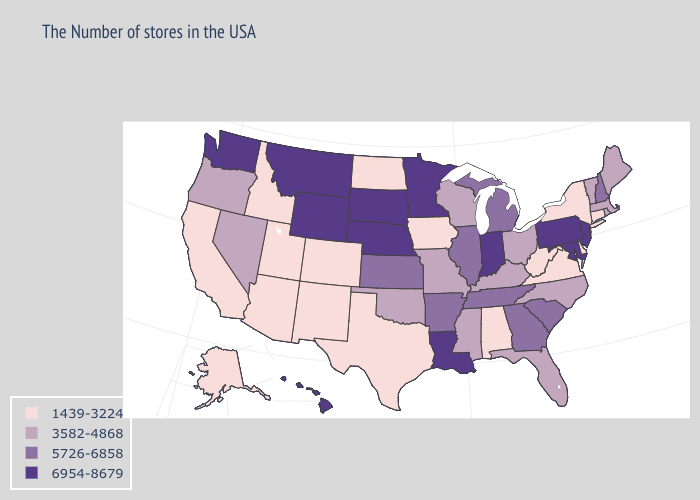Does New Jersey have the highest value in the USA?
Concise answer only. Yes. Does Minnesota have a lower value than Oklahoma?
Be succinct. No. Does Vermont have the same value as Alaska?
Concise answer only. No. What is the value of Louisiana?
Be succinct. 6954-8679. Among the states that border New Mexico , which have the highest value?
Write a very short answer. Oklahoma. Which states hav the highest value in the West?
Quick response, please. Wyoming, Montana, Washington, Hawaii. Is the legend a continuous bar?
Be succinct. No. Name the states that have a value in the range 6954-8679?
Short answer required. New Jersey, Maryland, Pennsylvania, Indiana, Louisiana, Minnesota, Nebraska, South Dakota, Wyoming, Montana, Washington, Hawaii. What is the value of Michigan?
Write a very short answer. 5726-6858. What is the value of California?
Keep it brief. 1439-3224. What is the value of New Jersey?
Keep it brief. 6954-8679. Name the states that have a value in the range 5726-6858?
Concise answer only. New Hampshire, South Carolina, Georgia, Michigan, Tennessee, Illinois, Arkansas, Kansas. Among the states that border Wisconsin , which have the lowest value?
Answer briefly. Iowa. Among the states that border Wisconsin , does Michigan have the highest value?
Short answer required. No. Which states have the highest value in the USA?
Be succinct. New Jersey, Maryland, Pennsylvania, Indiana, Louisiana, Minnesota, Nebraska, South Dakota, Wyoming, Montana, Washington, Hawaii. 